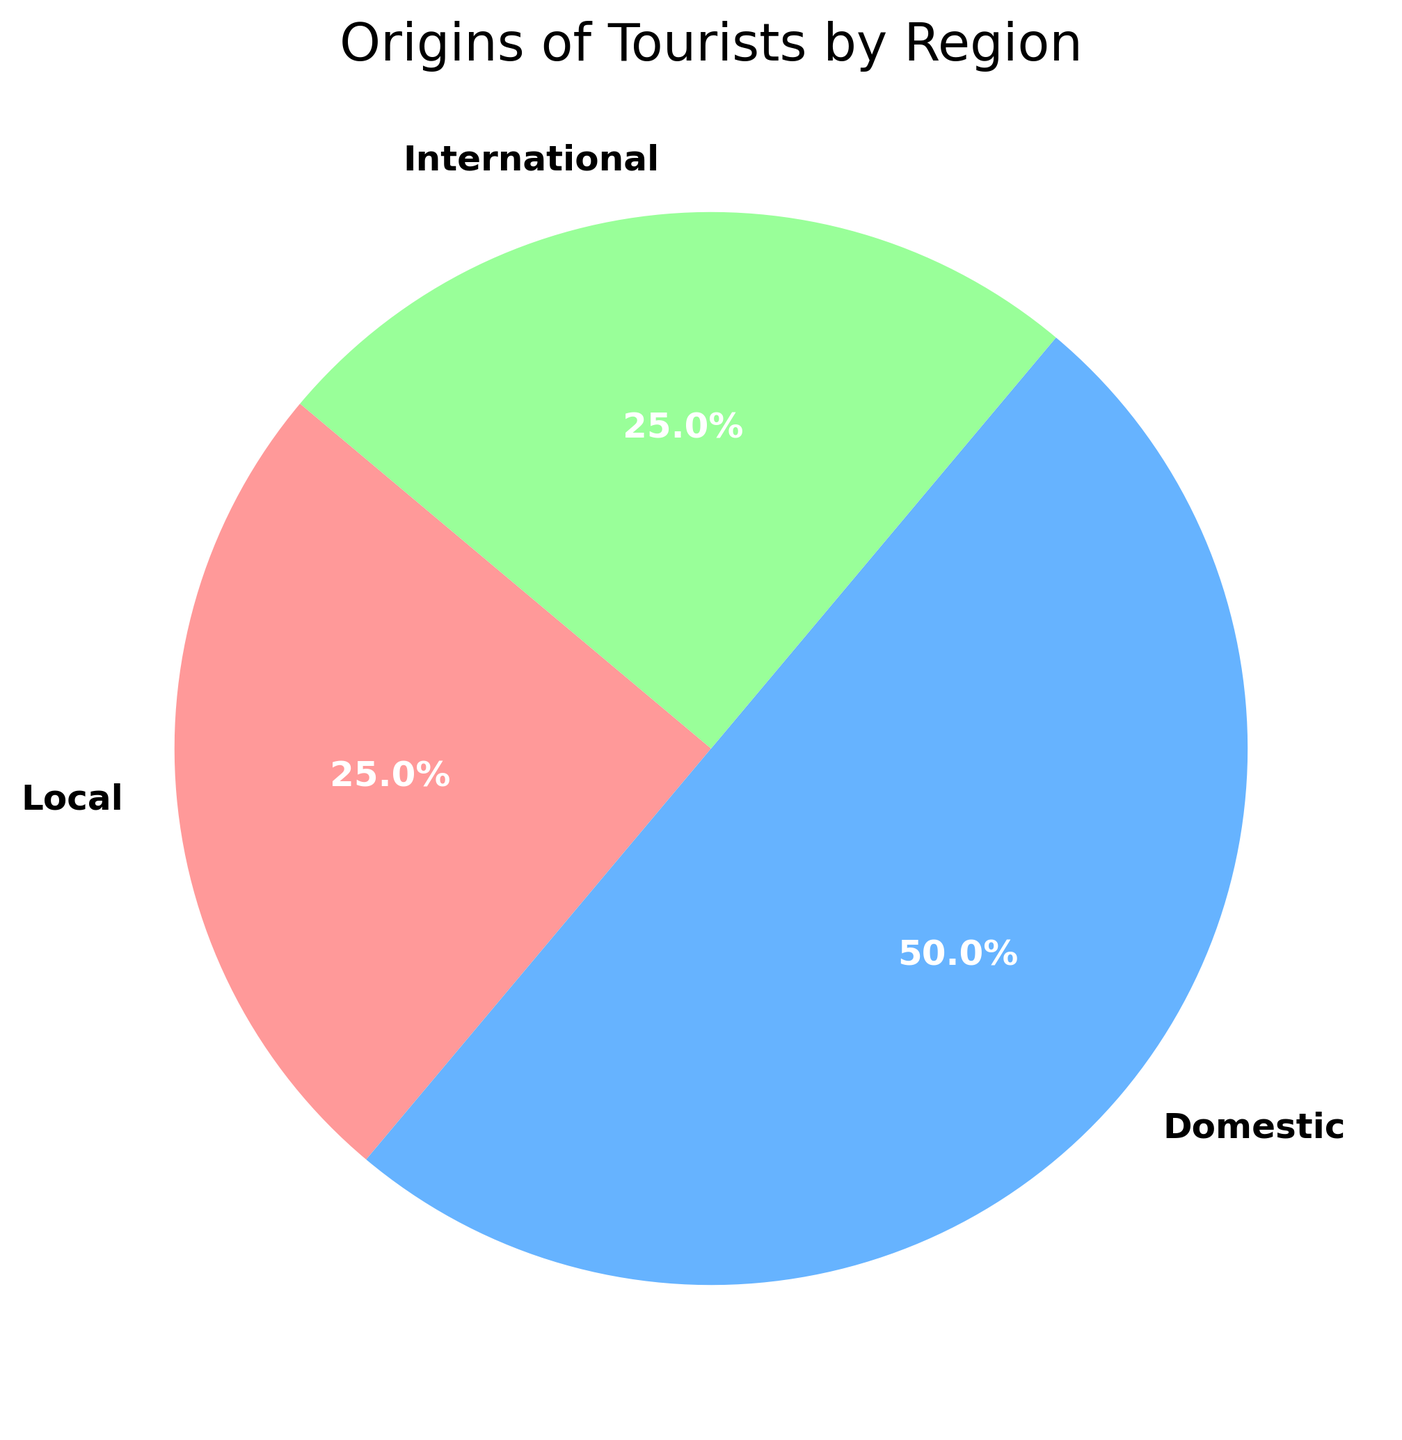What percentage of tourists are international? The pie chart shows a section labeled "International" with a specified percentage. By looking at this section, you can see the percentage of international tourists.
Answer: 25% What is the difference in percentage between domestic and local tourists? Identify the segments labeled "Domestic" and "Local." Note their respective percentages: 50% for Domestic and 25% for Local. Subtract the local percentage from the domestic percentage (50% - 25%).
Answer: 25% Which region contributes the most tourists? Examine the pie chart sections. The largest section will correspond to the region with the highest percentage.
Answer: Domestic How many regions have equal percentages? By observing the pie chart, you can see that the Local and International sections both have a 25% slice, which are equal.
Answer: 2 What is the combined percentage of Local and International tourists? Identify the percentages for Local (25%) and International (25%) from the pie chart. Add these percentages together (25% + 25%).
Answer: 50% Are there more domestic tourists than the combined total of local and international tourists? First, find the combined total of Local and International tourists (25% + 25% = 50%). Compare this total with the Domestic tourist percentage (50%). Since both are equal, there are not more Domestic tourists.
Answer: No What section of the pie chart is represented by the color green? Look at the section colored green and match it with its corresponding label to identify the region it represents.
Answer: International How much greater is the domestic percentage compared to the smallest category? Identify the percentages for Domestic (50%) and the smallest category, either Local or International (25%). Subtract the smallest percentage from the domestic percentage (50% - 25%).
Answer: 25% Which region has the smallest ratio compared to the whole chart? Find the slices with the smallest percentages, which are both Local and International at 25%.
Answer: Local and International If Local tourists increased by 10%, what would be the new percentage of Local tourists? Start with the original Local percentage (25%) and add 10% to this value: 25% + 10%.
Answer: 35% 